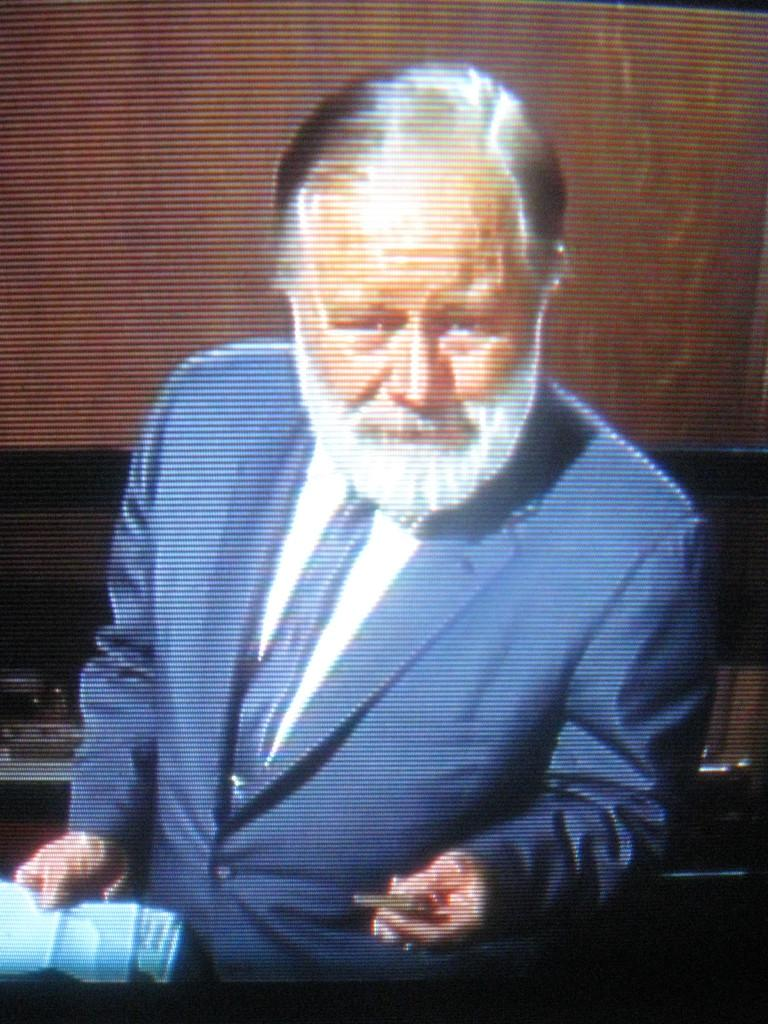What is the main subject of the image? There is a person in the image. Can you describe the person's attire? The person is wearing clothes. What is the person doing with his hands in the image? The person is holding objects with his hands. How many kittens are sitting on the person's shoulders in the image? There are no kittens present in the image. What type of picture is the person holding in the image? There is no picture visible in the person's hands in the image. 